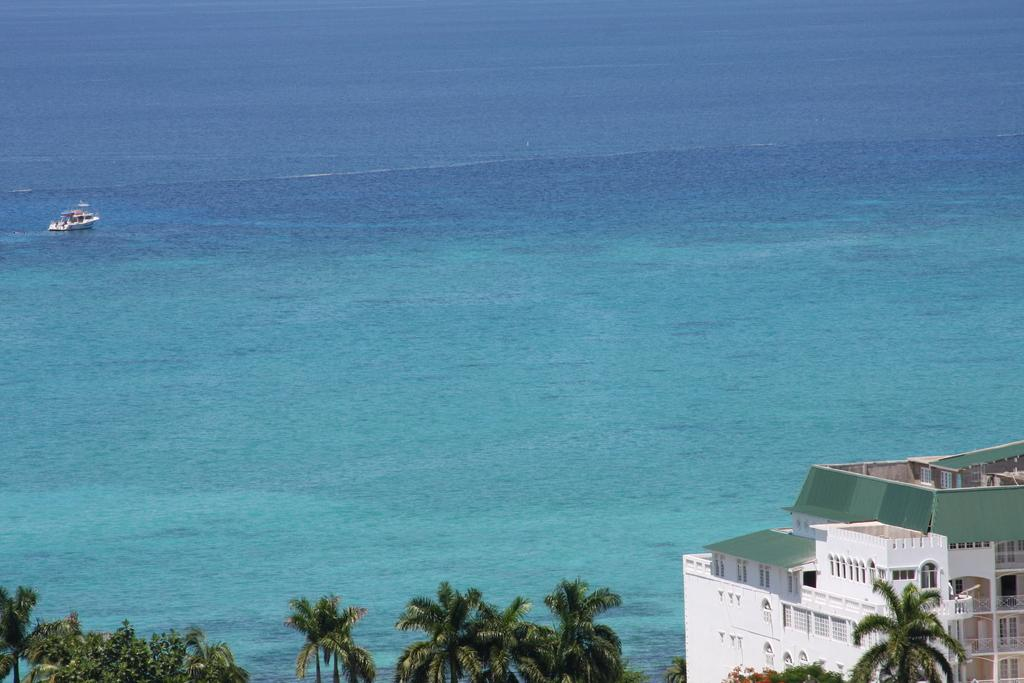What is the main subject of the image? The main subject of the image is a ship. What is the ship's location in relation to the water? The ship is floating on water. What type of vegetation can be seen in the image? There are trees visible in the image. Can you describe the building in the image? There is a building with windows in the image. What type of squirrel can be seen climbing the ship's mast in the image? There is no squirrel present in the image; it only features a ship, water, trees, and a building with windows. Can you tell me how many pickles are on the ship's deck in the image? There are no pickles present in the image; it only features a ship, water, trees, and a building with windows. 